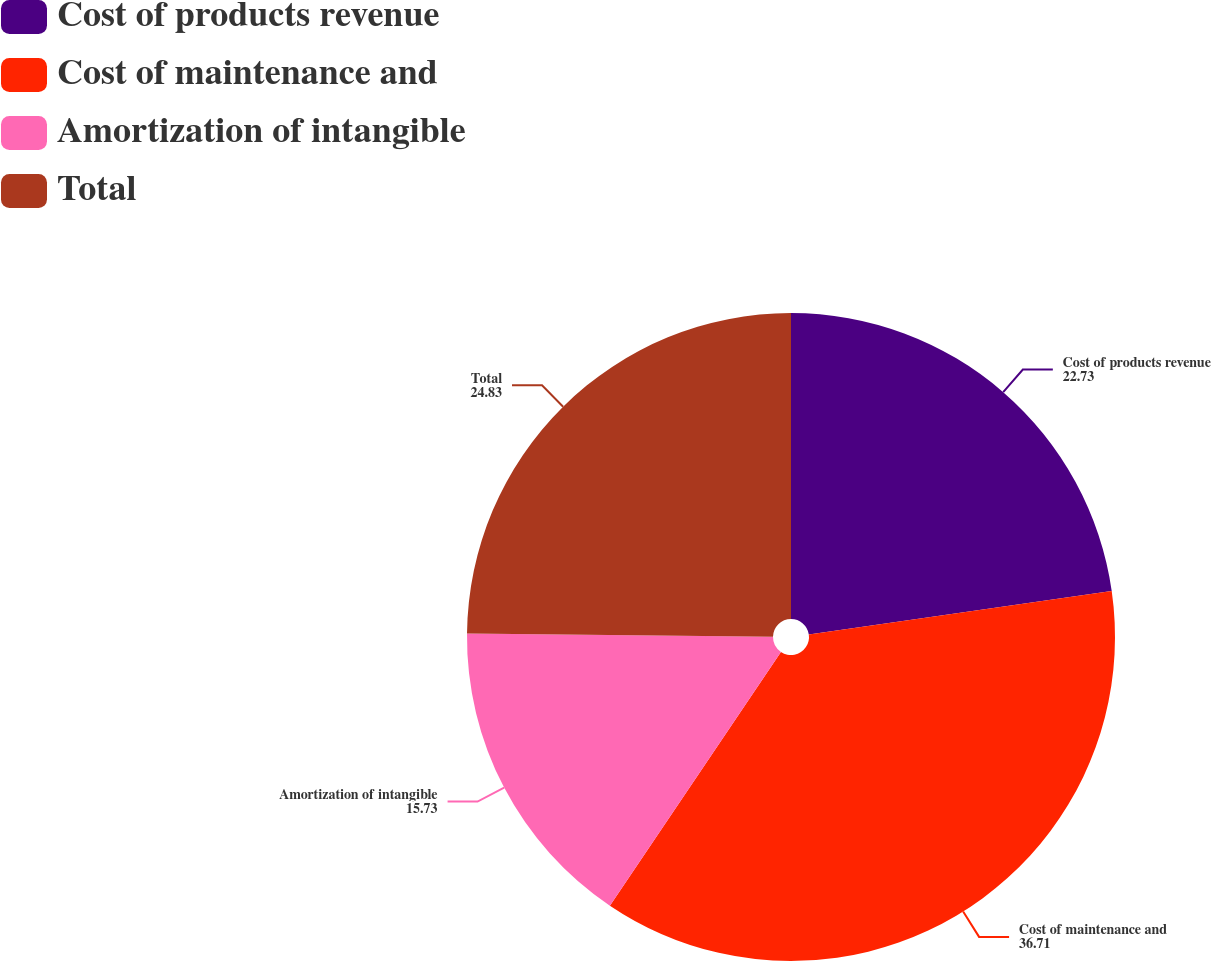<chart> <loc_0><loc_0><loc_500><loc_500><pie_chart><fcel>Cost of products revenue<fcel>Cost of maintenance and<fcel>Amortization of intangible<fcel>Total<nl><fcel>22.73%<fcel>36.71%<fcel>15.73%<fcel>24.83%<nl></chart> 